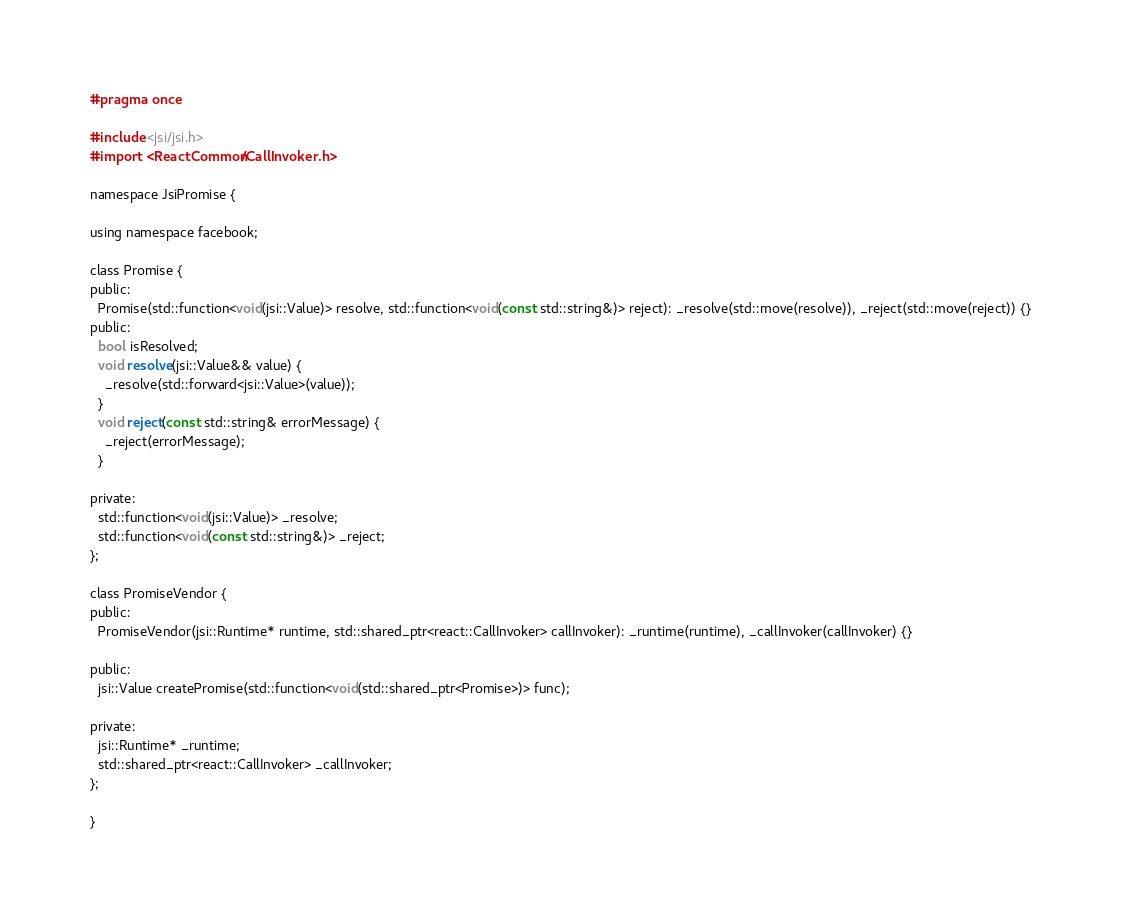Convert code to text. <code><loc_0><loc_0><loc_500><loc_500><_C_>#pragma once

#include <jsi/jsi.h>
#import <ReactCommon/CallInvoker.h>

namespace JsiPromise {

using namespace facebook;

class Promise {
public:
  Promise(std::function<void(jsi::Value)> resolve, std::function<void(const std::string&)> reject): _resolve(std::move(resolve)), _reject(std::move(reject)) {}
public:
  bool isResolved;
  void resolve(jsi::Value&& value) {
    _resolve(std::forward<jsi::Value>(value));
  }
  void reject(const std::string& errorMessage) {
    _reject(errorMessage);
  }
  
private:
  std::function<void(jsi::Value)> _resolve;
  std::function<void(const std::string&)> _reject;
};

class PromiseVendor {
public:
  PromiseVendor(jsi::Runtime* runtime, std::shared_ptr<react::CallInvoker> callInvoker): _runtime(runtime), _callInvoker(callInvoker) {}
  
public:
  jsi::Value createPromise(std::function<void(std::shared_ptr<Promise>)> func);
  
private:
  jsi::Runtime* _runtime;
  std::shared_ptr<react::CallInvoker> _callInvoker;
};

}

</code> 